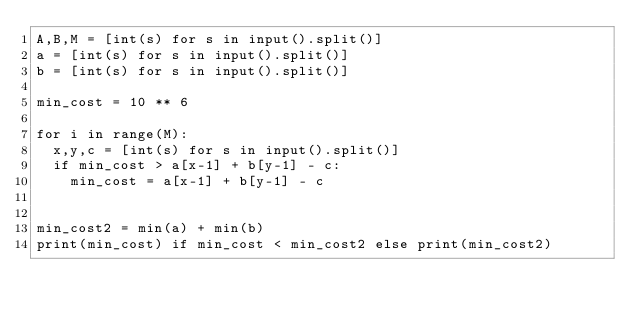Convert code to text. <code><loc_0><loc_0><loc_500><loc_500><_Python_>A,B,M = [int(s) for s in input().split()]
a = [int(s) for s in input().split()]
b = [int(s) for s in input().split()]

min_cost = 10 ** 6

for i in range(M):
  x,y,c = [int(s) for s in input().split()]
  if min_cost > a[x-1] + b[y-1] - c:
    min_cost = a[x-1] + b[y-1] - c
    
    
min_cost2 = min(a) + min(b)
print(min_cost) if min_cost < min_cost2 else print(min_cost2) </code> 